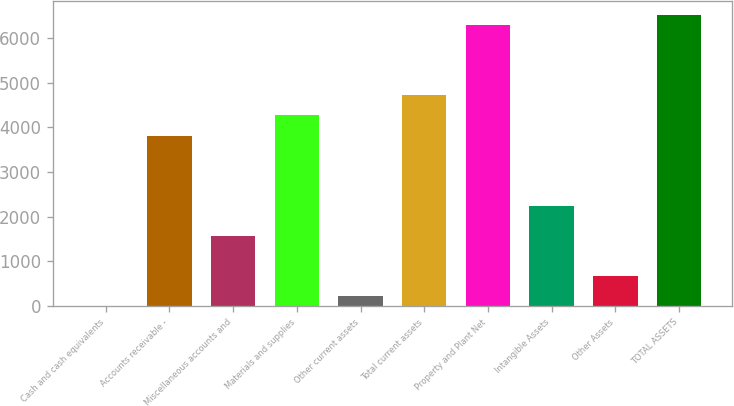Convert chart to OTSL. <chart><loc_0><loc_0><loc_500><loc_500><bar_chart><fcel>Cash and cash equivalents<fcel>Accounts receivable -<fcel>Miscellaneous accounts and<fcel>Materials and supplies<fcel>Other current assets<fcel>Total current assets<fcel>Property and Plant Net<fcel>Intangible Assets<fcel>Other Assets<fcel>TOTAL ASSETS<nl><fcel>2<fcel>3813.4<fcel>1571.4<fcel>4261.8<fcel>226.2<fcel>4710.2<fcel>6279.6<fcel>2244<fcel>674.6<fcel>6503.8<nl></chart> 